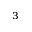<formula> <loc_0><loc_0><loc_500><loc_500>^ { 3 }</formula> 